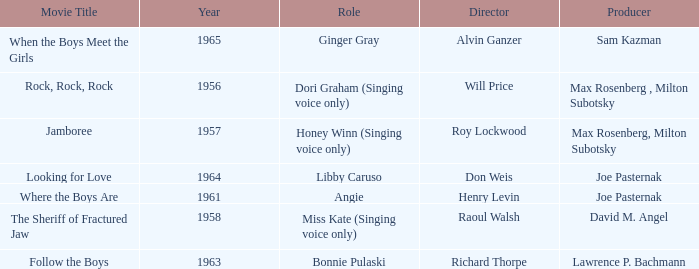Who were the producers in 1961? Joe Pasternak. 